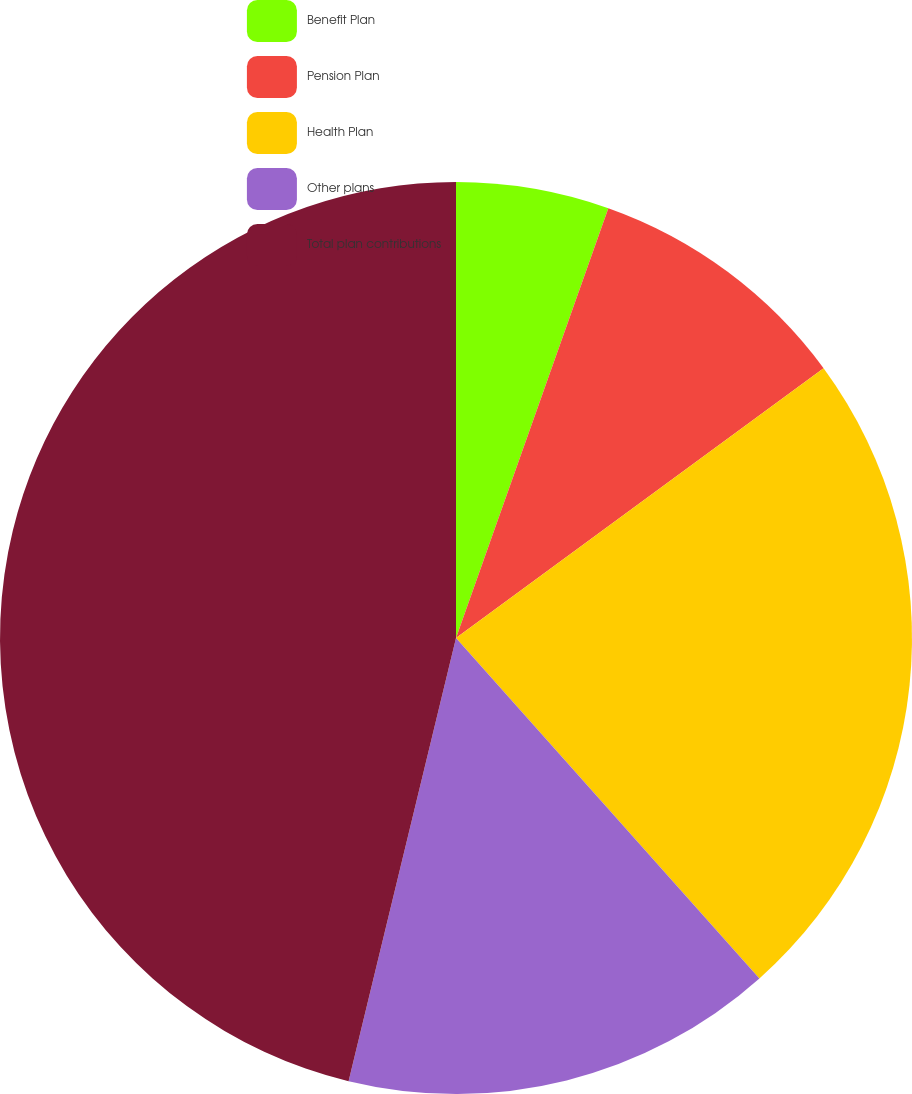<chart> <loc_0><loc_0><loc_500><loc_500><pie_chart><fcel>Benefit Plan<fcel>Pension Plan<fcel>Health Plan<fcel>Other plans<fcel>Total plan contributions<nl><fcel>5.42%<fcel>9.5%<fcel>23.49%<fcel>15.37%<fcel>46.21%<nl></chart> 